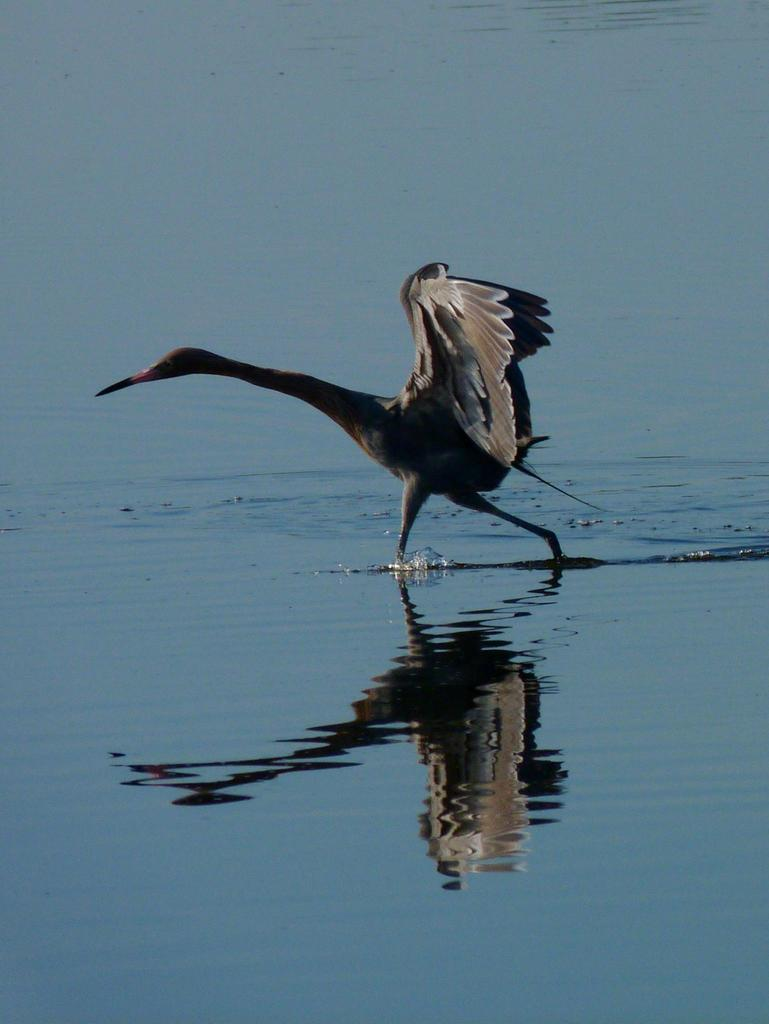What type of animal is in the image? There is a bird in the image. Where is the bird located? The bird is in the water. Can you describe the possible location where the image was taken? The image may have been taken at a lake. What type of competition is the bird participating in within the image? There is no competition present in the image; it simply shows a bird in the water. 